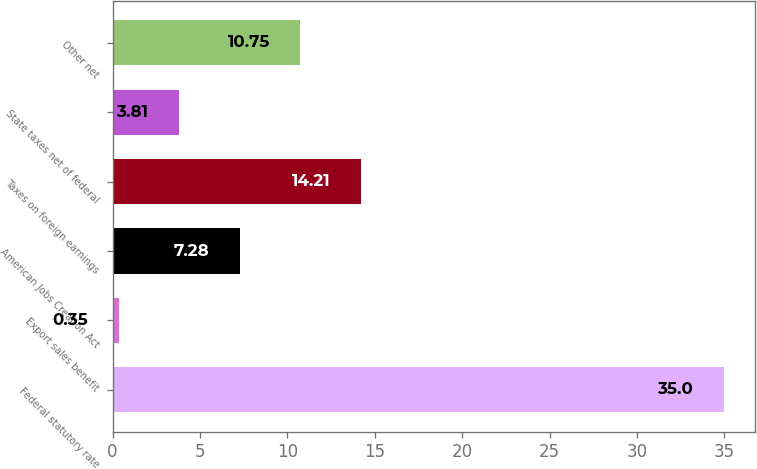<chart> <loc_0><loc_0><loc_500><loc_500><bar_chart><fcel>Federal statutory rate<fcel>Export sales benefit<fcel>American Jobs Creation Act<fcel>Taxes on foreign earnings<fcel>State taxes net of federal<fcel>Other net<nl><fcel>35<fcel>0.35<fcel>7.28<fcel>14.21<fcel>3.81<fcel>10.75<nl></chart> 